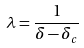<formula> <loc_0><loc_0><loc_500><loc_500>\lambda = \frac { 1 } { \delta - \delta _ { c } }</formula> 